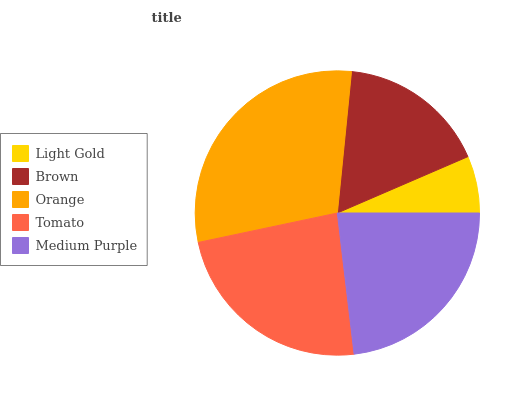Is Light Gold the minimum?
Answer yes or no. Yes. Is Orange the maximum?
Answer yes or no. Yes. Is Brown the minimum?
Answer yes or no. No. Is Brown the maximum?
Answer yes or no. No. Is Brown greater than Light Gold?
Answer yes or no. Yes. Is Light Gold less than Brown?
Answer yes or no. Yes. Is Light Gold greater than Brown?
Answer yes or no. No. Is Brown less than Light Gold?
Answer yes or no. No. Is Medium Purple the high median?
Answer yes or no. Yes. Is Medium Purple the low median?
Answer yes or no. Yes. Is Tomato the high median?
Answer yes or no. No. Is Brown the low median?
Answer yes or no. No. 